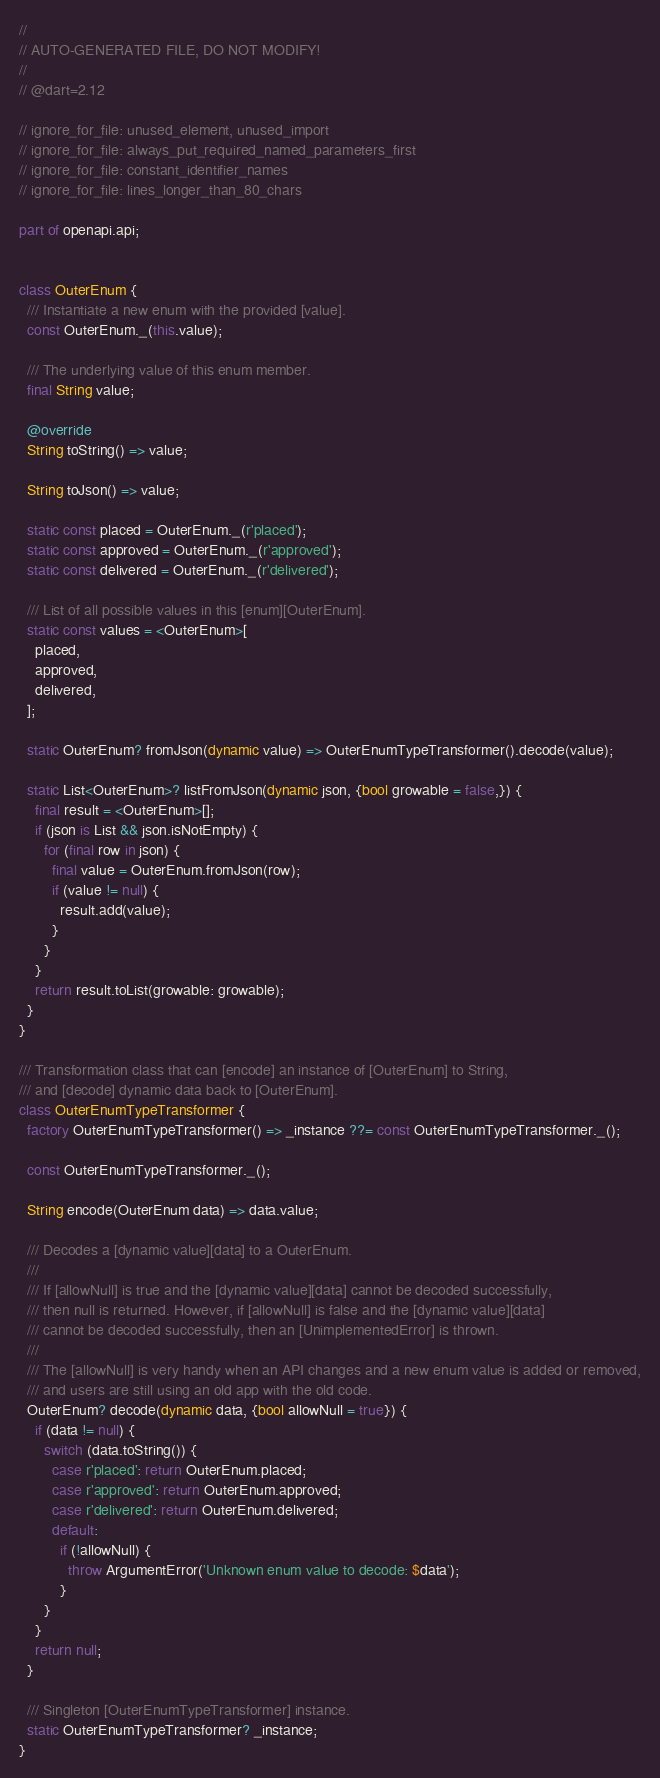Convert code to text. <code><loc_0><loc_0><loc_500><loc_500><_Dart_>//
// AUTO-GENERATED FILE, DO NOT MODIFY!
//
// @dart=2.12

// ignore_for_file: unused_element, unused_import
// ignore_for_file: always_put_required_named_parameters_first
// ignore_for_file: constant_identifier_names
// ignore_for_file: lines_longer_than_80_chars

part of openapi.api;


class OuterEnum {
  /// Instantiate a new enum with the provided [value].
  const OuterEnum._(this.value);

  /// The underlying value of this enum member.
  final String value;

  @override
  String toString() => value;

  String toJson() => value;

  static const placed = OuterEnum._(r'placed');
  static const approved = OuterEnum._(r'approved');
  static const delivered = OuterEnum._(r'delivered');

  /// List of all possible values in this [enum][OuterEnum].
  static const values = <OuterEnum>[
    placed,
    approved,
    delivered,
  ];

  static OuterEnum? fromJson(dynamic value) => OuterEnumTypeTransformer().decode(value);

  static List<OuterEnum>? listFromJson(dynamic json, {bool growable = false,}) {
    final result = <OuterEnum>[];
    if (json is List && json.isNotEmpty) {
      for (final row in json) {
        final value = OuterEnum.fromJson(row);
        if (value != null) {
          result.add(value);
        }
      }
    }
    return result.toList(growable: growable);
  }
}

/// Transformation class that can [encode] an instance of [OuterEnum] to String,
/// and [decode] dynamic data back to [OuterEnum].
class OuterEnumTypeTransformer {
  factory OuterEnumTypeTransformer() => _instance ??= const OuterEnumTypeTransformer._();

  const OuterEnumTypeTransformer._();

  String encode(OuterEnum data) => data.value;

  /// Decodes a [dynamic value][data] to a OuterEnum.
  ///
  /// If [allowNull] is true and the [dynamic value][data] cannot be decoded successfully,
  /// then null is returned. However, if [allowNull] is false and the [dynamic value][data]
  /// cannot be decoded successfully, then an [UnimplementedError] is thrown.
  ///
  /// The [allowNull] is very handy when an API changes and a new enum value is added or removed,
  /// and users are still using an old app with the old code.
  OuterEnum? decode(dynamic data, {bool allowNull = true}) {
    if (data != null) {
      switch (data.toString()) {
        case r'placed': return OuterEnum.placed;
        case r'approved': return OuterEnum.approved;
        case r'delivered': return OuterEnum.delivered;
        default:
          if (!allowNull) {
            throw ArgumentError('Unknown enum value to decode: $data');
          }
      }
    }
    return null;
  }

  /// Singleton [OuterEnumTypeTransformer] instance.
  static OuterEnumTypeTransformer? _instance;
}

</code> 